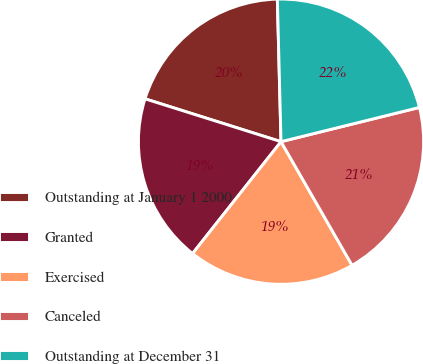<chart> <loc_0><loc_0><loc_500><loc_500><pie_chart><fcel>Outstanding at January 1 2000<fcel>Granted<fcel>Exercised<fcel>Canceled<fcel>Outstanding at December 31<nl><fcel>19.73%<fcel>19.21%<fcel>18.95%<fcel>20.56%<fcel>21.55%<nl></chart> 